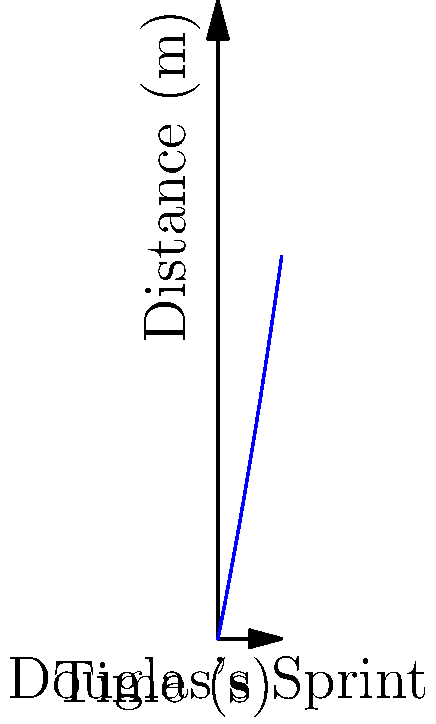Analyze the distance-time graph of Demario Douglas's sprint. If he maintains this pattern for 15 seconds, what will be his average speed over the entire duration? To solve this problem, we need to follow these steps:

1. Understand the graph: The curve represents distance covered over time.

2. Determine the function: The graph appears to follow a quadratic function of the form $d = 5t + 0.1t^2$, where $d$ is distance in meters and $t$ is time in seconds.

3. Calculate the distance at 15 seconds:
   $d = 5(15) + 0.1(15^2) = 75 + 22.5 = 97.5$ meters

4. Calculate the average speed:
   Average speed = Total distance / Total time
   $v_{avg} = 97.5 \text{ m} / 15 \text{ s} = 6.5 \text{ m/s}$

5. Convert to km/h for a more familiar unit:
   $6.5 \text{ m/s} * (3600 \text{ s}/1 \text{ h}) * (1 \text{ km}/1000 \text{ m}) = 23.4 \text{ km/h}$

Therefore, Douglas's average speed over the 15-second sprint would be 6.5 m/s or 23.4 km/h.
Answer: 23.4 km/h 